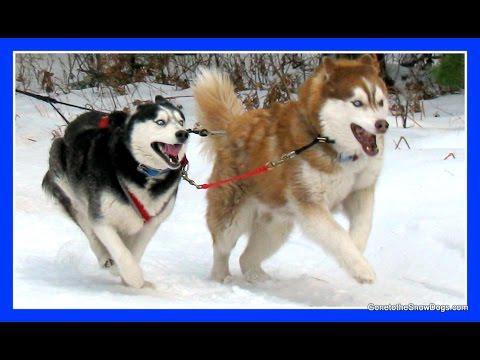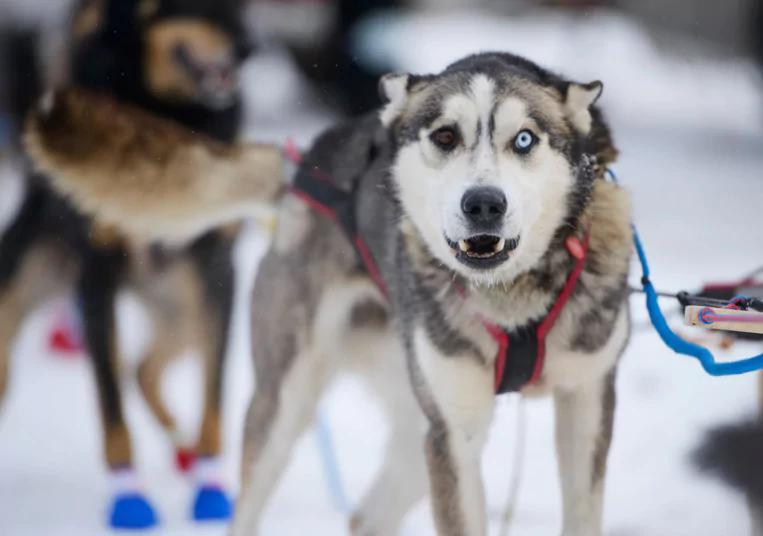The first image is the image on the left, the second image is the image on the right. Given the left and right images, does the statement "There are dogs wearing colorful paw coverups." hold true? Answer yes or no. Yes. 